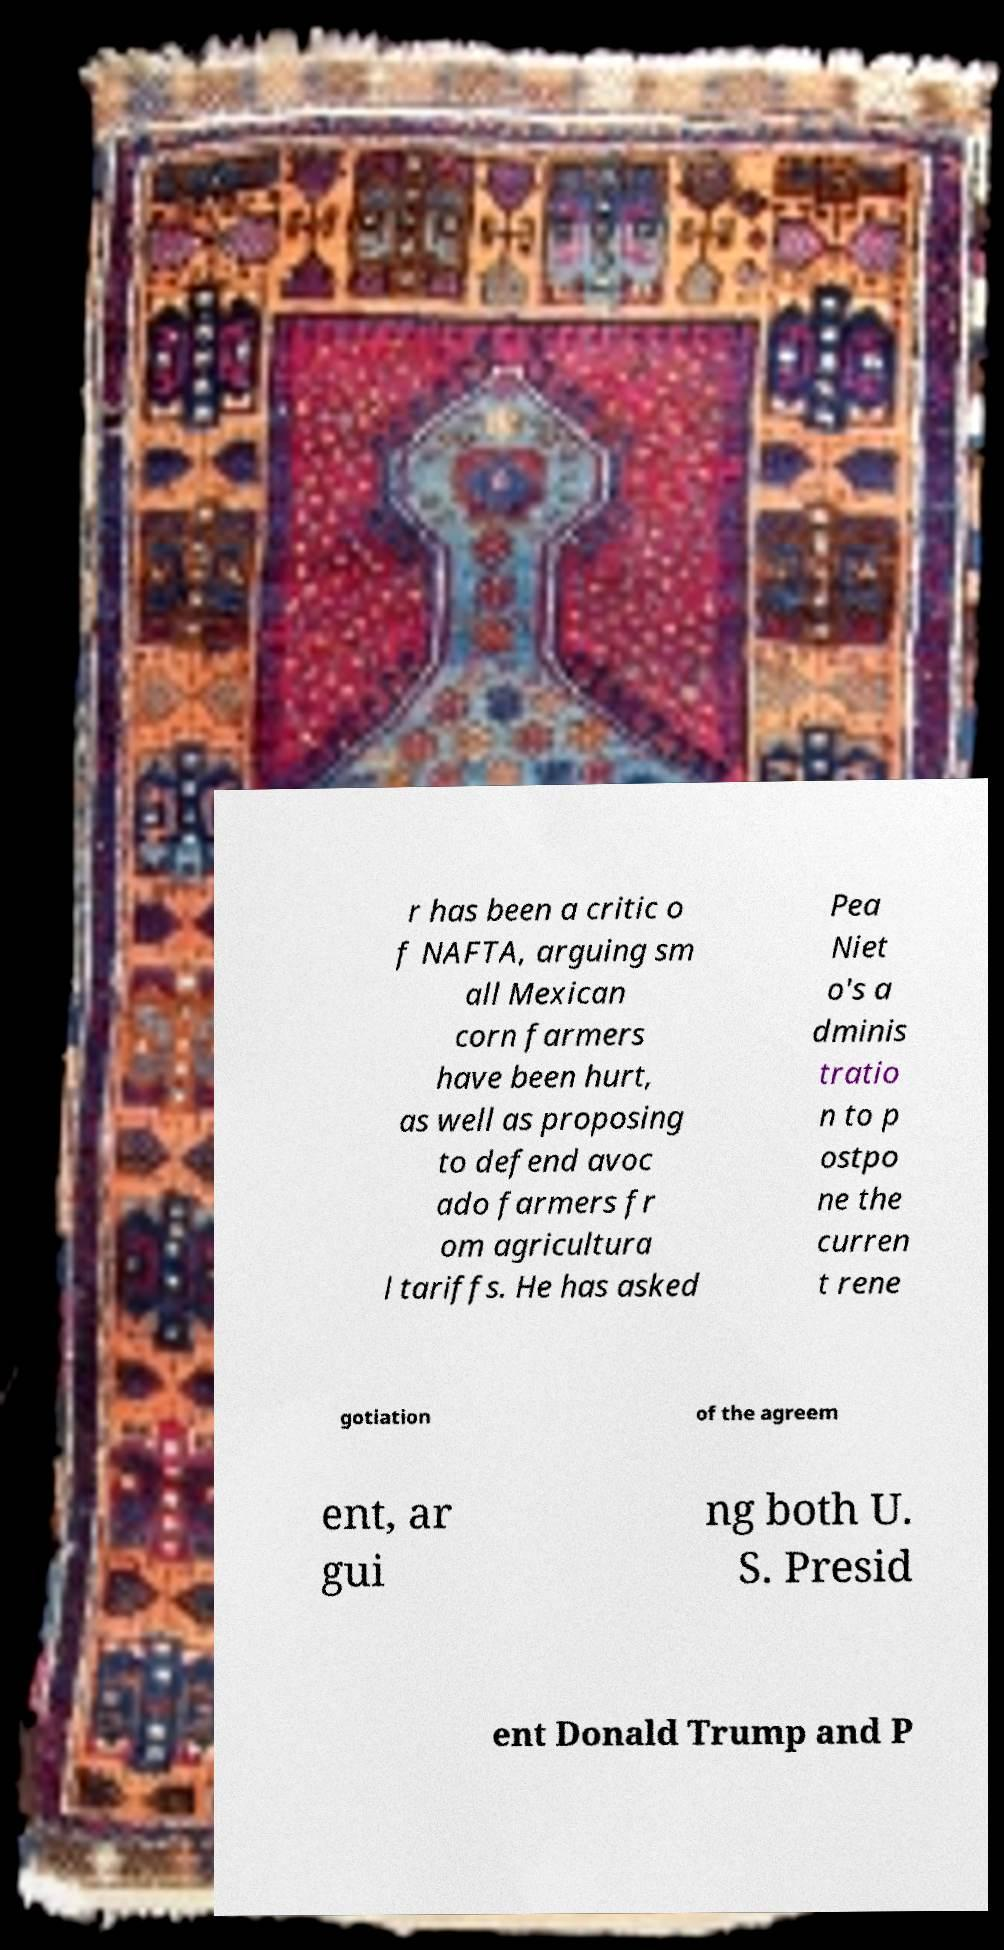What messages or text are displayed in this image? I need them in a readable, typed format. r has been a critic o f NAFTA, arguing sm all Mexican corn farmers have been hurt, as well as proposing to defend avoc ado farmers fr om agricultura l tariffs. He has asked Pea Niet o's a dminis tratio n to p ostpo ne the curren t rene gotiation of the agreem ent, ar gui ng both U. S. Presid ent Donald Trump and P 